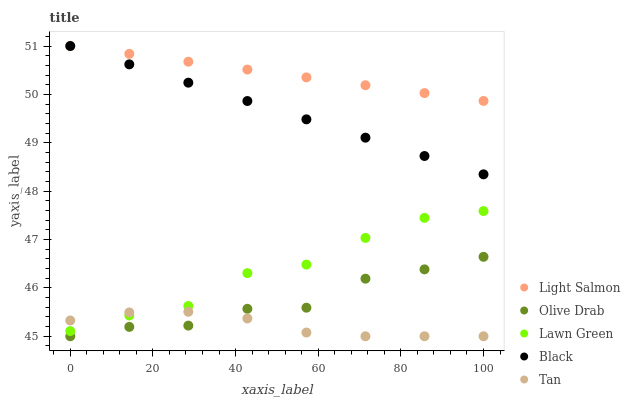Does Tan have the minimum area under the curve?
Answer yes or no. Yes. Does Light Salmon have the maximum area under the curve?
Answer yes or no. Yes. Does Black have the minimum area under the curve?
Answer yes or no. No. Does Black have the maximum area under the curve?
Answer yes or no. No. Is Light Salmon the smoothest?
Answer yes or no. Yes. Is Lawn Green the roughest?
Answer yes or no. Yes. Is Black the smoothest?
Answer yes or no. No. Is Black the roughest?
Answer yes or no. No. Does Tan have the lowest value?
Answer yes or no. Yes. Does Black have the lowest value?
Answer yes or no. No. Does Black have the highest value?
Answer yes or no. Yes. Does Tan have the highest value?
Answer yes or no. No. Is Olive Drab less than Light Salmon?
Answer yes or no. Yes. Is Light Salmon greater than Olive Drab?
Answer yes or no. Yes. Does Light Salmon intersect Black?
Answer yes or no. Yes. Is Light Salmon less than Black?
Answer yes or no. No. Is Light Salmon greater than Black?
Answer yes or no. No. Does Olive Drab intersect Light Salmon?
Answer yes or no. No. 